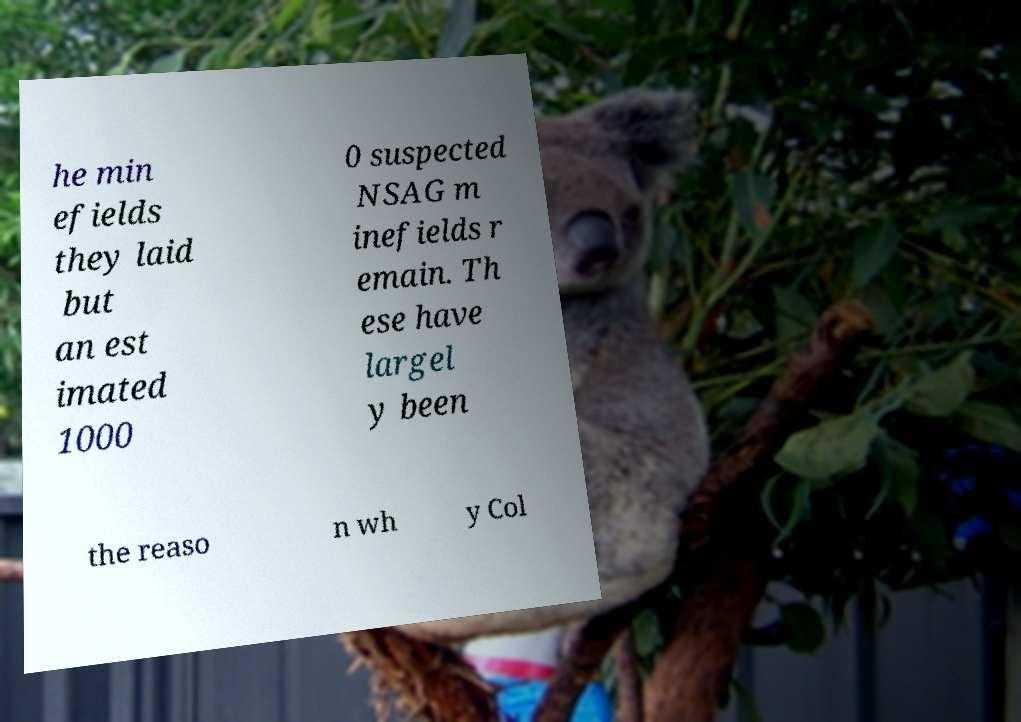For documentation purposes, I need the text within this image transcribed. Could you provide that? he min efields they laid but an est imated 1000 0 suspected NSAG m inefields r emain. Th ese have largel y been the reaso n wh y Col 